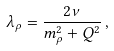<formula> <loc_0><loc_0><loc_500><loc_500>\lambda _ { \rho } = \frac { 2 \nu } { m _ { \rho } ^ { 2 } + Q ^ { 2 } } \, ,</formula> 